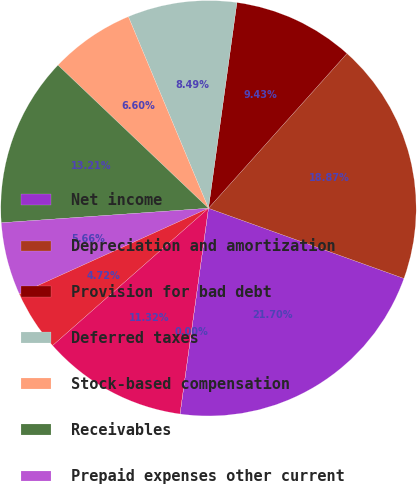Convert chart. <chart><loc_0><loc_0><loc_500><loc_500><pie_chart><fcel>Net income<fcel>Depreciation and amortization<fcel>Provision for bad debt<fcel>Deferred taxes<fcel>Stock-based compensation<fcel>Receivables<fcel>Prepaid expenses other current<fcel>Accounts payable accrued<fcel>Deferred revenue other current<fcel>Income tax receivables accrued<nl><fcel>21.7%<fcel>18.87%<fcel>9.43%<fcel>8.49%<fcel>6.6%<fcel>13.21%<fcel>5.66%<fcel>4.72%<fcel>11.32%<fcel>0.0%<nl></chart> 